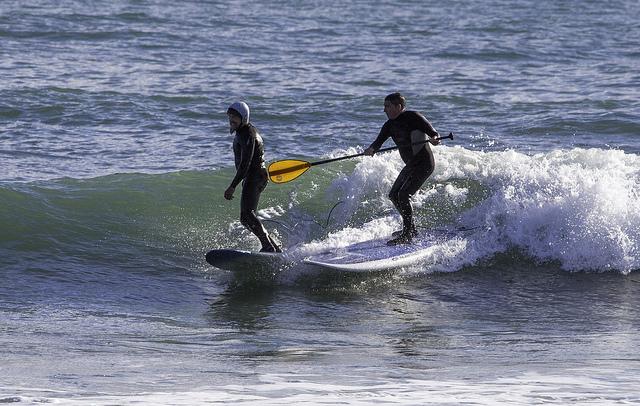How many of these people are holding a paddle?
Keep it brief. 1. What is the woman riding?
Be succinct. Surfboard. What activity is he engaged in?
Give a very brief answer. Surfing. How many people are in the water?
Short answer required. 2. How is the wakeboard moved through the water?
Give a very brief answer. Paddle. Why is this person wet?
Concise answer only. Surfing. How many people are in the picture?
Keep it brief. 2. Is this a beach?
Concise answer only. Yes. What gender are the people in the photo?
Answer briefly. Male. 